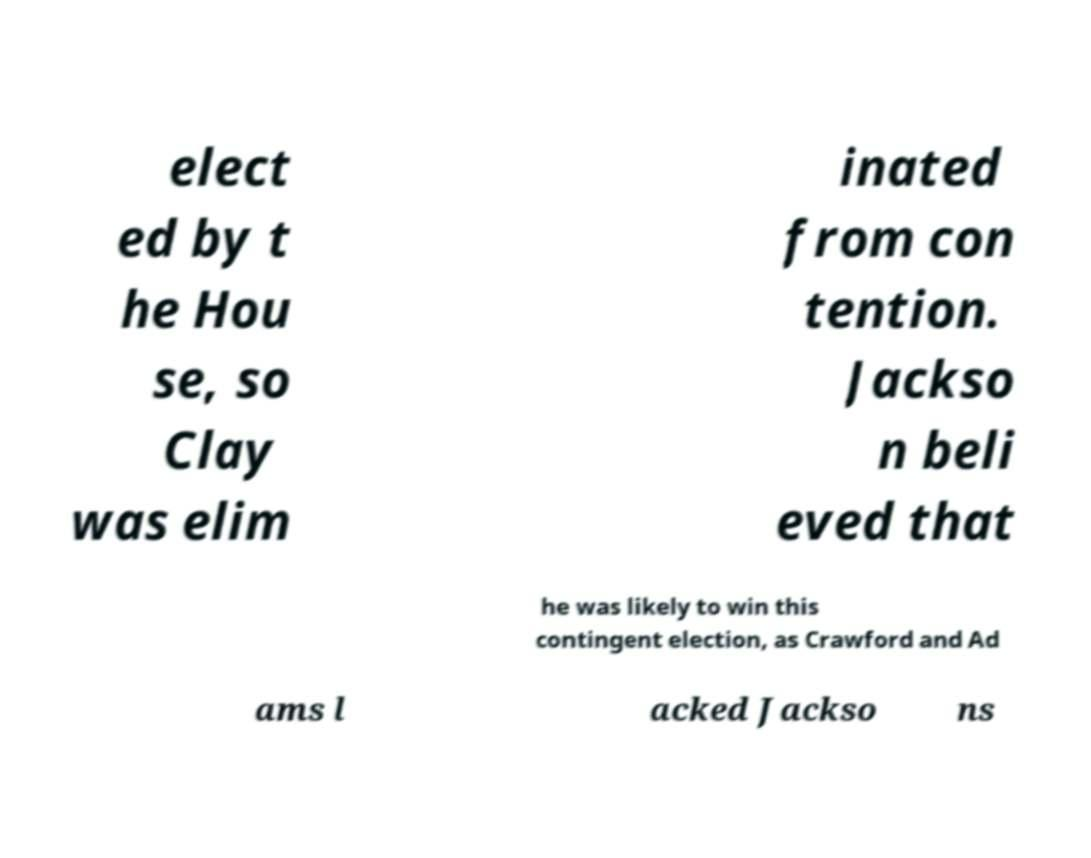Please read and relay the text visible in this image. What does it say? elect ed by t he Hou se, so Clay was elim inated from con tention. Jackso n beli eved that he was likely to win this contingent election, as Crawford and Ad ams l acked Jackso ns 